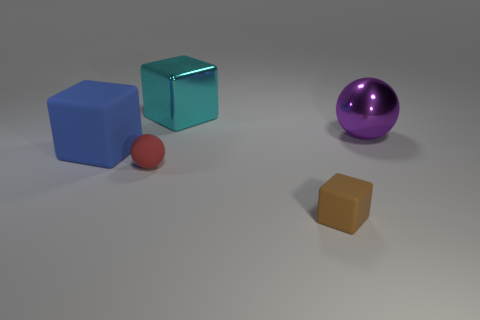Subtract 1 blocks. How many blocks are left? 2 Add 4 big cyan cylinders. How many objects exist? 9 Subtract all big blue rubber cubes. How many cubes are left? 2 Subtract all spheres. How many objects are left? 3 Subtract all purple things. Subtract all cyan metallic things. How many objects are left? 3 Add 3 matte balls. How many matte balls are left? 4 Add 5 purple balls. How many purple balls exist? 6 Subtract 1 blue blocks. How many objects are left? 4 